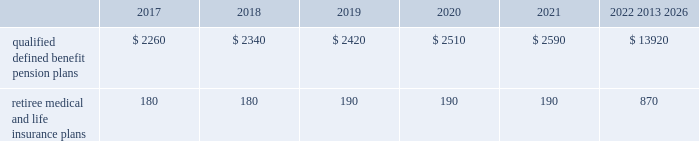Contributions and expected benefit payments the funding of our qualified defined benefit pension plans is determined in accordance with erisa , as amended by the ppa , and in a manner consistent with cas and internal revenue code rules .
There were no contributions to our legacy qualified defined benefit pension plans during 2016 .
We do not plan to make contributions to our legacy pension plans in 2017 because none are required using current assumptions including investment returns on plan assets .
We made $ 23 million in contributions during 2016 to our newly established sikorsky pension plan and expect to make $ 45 million in contributions to this plan during 2017 .
The table presents estimated future benefit payments , which reflect expected future employee service , as of december 31 , 2016 ( in millions ) : .
Defined contribution plans we maintain a number of defined contribution plans , most with 401 ( k ) features , that cover substantially all of our employees .
Under the provisions of our 401 ( k ) plans , we match most employees 2019 eligible contributions at rates specified in the plan documents .
Our contributions were $ 617 million in 2016 , $ 393 million in 2015 and $ 385 million in 2014 , the majority of which were funded in our common stock .
Our defined contribution plans held approximately 36.9 million and 40.0 million shares of our common stock as of december 31 , 2016 and 2015 .
Note 12 2013 stockholders 2019 equity at december 31 , 2016 and 2015 , our authorized capital was composed of 1.5 billion shares of common stock and 50 million shares of series preferred stock .
Of the 290 million shares of common stock issued and outstanding as of december 31 , 2016 , 289 million shares were considered outstanding for consolidated balance sheet presentation purposes ; the remaining shares were held in a separate trust .
Of the 305 million shares of common stock issued and outstanding as of december 31 , 2015 , 303 million shares were considered outstanding for consolidated balance sheet presentation purposes ; the remaining shares were held in a separate trust .
No shares of preferred stock were issued and outstanding at december 31 , 2016 or 2015 .
Repurchases of common stock during 2016 , we repurchased 8.9 million shares of our common stock for $ 2.1 billion .
During 2015 and 2014 , we paid $ 3.1 billion and $ 1.9 billion to repurchase 15.2 million and 11.5 million shares of our common stock .
On september 22 , 2016 , our board of directors approved a $ 2.0 billion increase to our share repurchase program .
Inclusive of this increase , the total remaining authorization for future common share repurchases under our program was $ 3.5 billion as of december 31 , 2016 .
As we repurchase our common shares , we reduce common stock for the $ 1 of par value of the shares repurchased , with the excess purchase price over par value recorded as a reduction of additional paid-in capital .
Due to the volume of repurchases made under our share repurchase program , additional paid-in capital was reduced to zero , with the remainder of the excess purchase price over par value of $ 1.7 billion and $ 2.4 billion recorded as a reduction of retained earnings in 2016 and 2015 .
We paid dividends totaling $ 2.0 billion ( $ 6.77 per share ) in 2016 , $ 1.9 billion ( $ 6.15 per share ) in 2015 and $ 1.8 billion ( $ 5.49 per share ) in 2014 .
We have increased our quarterly dividend rate in each of the last three years , including a 10% ( 10 % ) increase in the quarterly dividend rate in the fourth quarter of 2016 .
We declared quarterly dividends of $ 1.65 per share during each of the first three quarters of 2016 and $ 1.82 per share during the fourth quarter of 2016 ; $ 1.50 per share during each of the first three quarters of 2015 and $ 1.65 per share during the fourth quarter of 2015 ; and $ 1.33 per share during each of the first three quarters of 2014 and $ 1.50 per share during the fourth quarter of 2014. .
What is the total outstanding number of shares that received dividends in 2016 , ( in millions ) ? 
Computations: ((2.0 * 1000) / 6.77)
Answer: 295.42097. Contributions and expected benefit payments the funding of our qualified defined benefit pension plans is determined in accordance with erisa , as amended by the ppa , and in a manner consistent with cas and internal revenue code rules .
There were no contributions to our legacy qualified defined benefit pension plans during 2016 .
We do not plan to make contributions to our legacy pension plans in 2017 because none are required using current assumptions including investment returns on plan assets .
We made $ 23 million in contributions during 2016 to our newly established sikorsky pension plan and expect to make $ 45 million in contributions to this plan during 2017 .
The table presents estimated future benefit payments , which reflect expected future employee service , as of december 31 , 2016 ( in millions ) : .
Defined contribution plans we maintain a number of defined contribution plans , most with 401 ( k ) features , that cover substantially all of our employees .
Under the provisions of our 401 ( k ) plans , we match most employees 2019 eligible contributions at rates specified in the plan documents .
Our contributions were $ 617 million in 2016 , $ 393 million in 2015 and $ 385 million in 2014 , the majority of which were funded in our common stock .
Our defined contribution plans held approximately 36.9 million and 40.0 million shares of our common stock as of december 31 , 2016 and 2015 .
Note 12 2013 stockholders 2019 equity at december 31 , 2016 and 2015 , our authorized capital was composed of 1.5 billion shares of common stock and 50 million shares of series preferred stock .
Of the 290 million shares of common stock issued and outstanding as of december 31 , 2016 , 289 million shares were considered outstanding for consolidated balance sheet presentation purposes ; the remaining shares were held in a separate trust .
Of the 305 million shares of common stock issued and outstanding as of december 31 , 2015 , 303 million shares were considered outstanding for consolidated balance sheet presentation purposes ; the remaining shares were held in a separate trust .
No shares of preferred stock were issued and outstanding at december 31 , 2016 or 2015 .
Repurchases of common stock during 2016 , we repurchased 8.9 million shares of our common stock for $ 2.1 billion .
During 2015 and 2014 , we paid $ 3.1 billion and $ 1.9 billion to repurchase 15.2 million and 11.5 million shares of our common stock .
On september 22 , 2016 , our board of directors approved a $ 2.0 billion increase to our share repurchase program .
Inclusive of this increase , the total remaining authorization for future common share repurchases under our program was $ 3.5 billion as of december 31 , 2016 .
As we repurchase our common shares , we reduce common stock for the $ 1 of par value of the shares repurchased , with the excess purchase price over par value recorded as a reduction of additional paid-in capital .
Due to the volume of repurchases made under our share repurchase program , additional paid-in capital was reduced to zero , with the remainder of the excess purchase price over par value of $ 1.7 billion and $ 2.4 billion recorded as a reduction of retained earnings in 2016 and 2015 .
We paid dividends totaling $ 2.0 billion ( $ 6.77 per share ) in 2016 , $ 1.9 billion ( $ 6.15 per share ) in 2015 and $ 1.8 billion ( $ 5.49 per share ) in 2014 .
We have increased our quarterly dividend rate in each of the last three years , including a 10% ( 10 % ) increase in the quarterly dividend rate in the fourth quarter of 2016 .
We declared quarterly dividends of $ 1.65 per share during each of the first three quarters of 2016 and $ 1.82 per share during the fourth quarter of 2016 ; $ 1.50 per share during each of the first three quarters of 2015 and $ 1.65 per share during the fourth quarter of 2015 ; and $ 1.33 per share during each of the first three quarters of 2014 and $ 1.50 per share during the fourth quarter of 2014. .
What is the change in millions of qualified defined benefit pension plans from 2018 to 2019 in estimated future benefit payments , which reflect expected future employee service , as of december 31 , 2016? 
Computations: (2420 - 2340)
Answer: 80.0. 